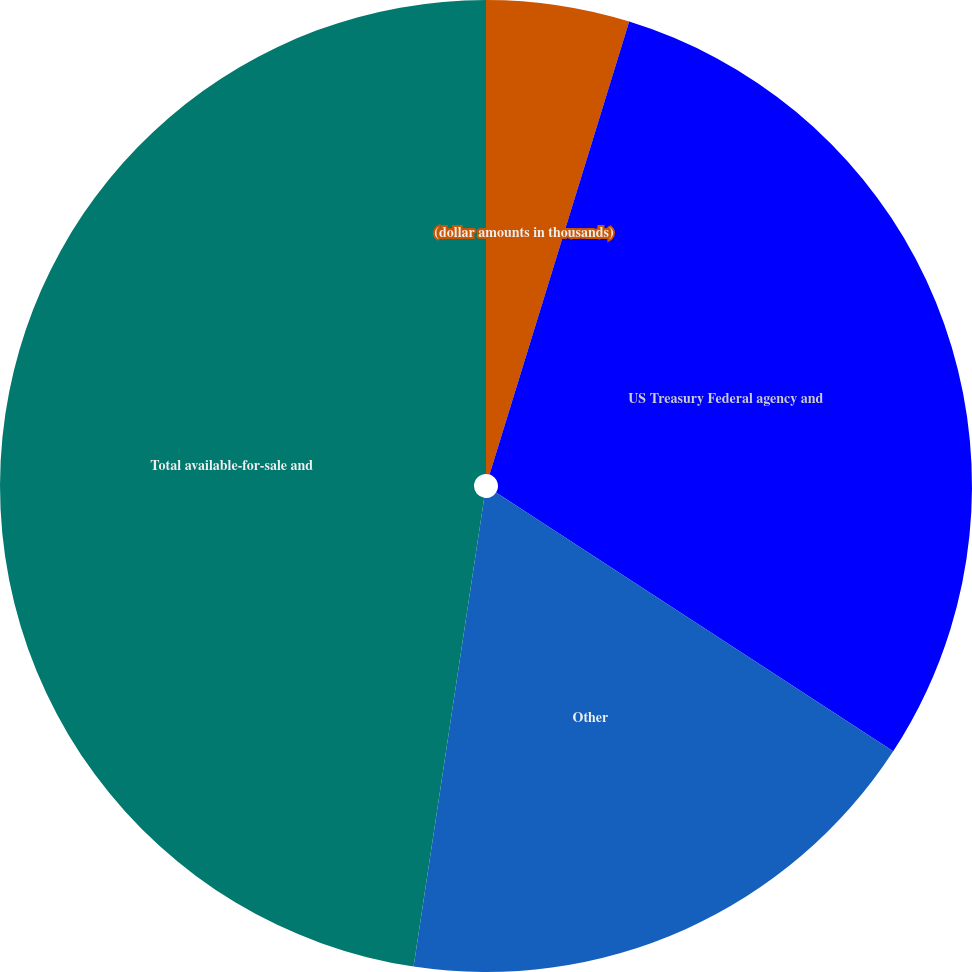<chart> <loc_0><loc_0><loc_500><loc_500><pie_chart><fcel>(dollar amounts in thousands)<fcel>US Treasury Federal agency and<fcel>Other<fcel>Total available-for-sale and<fcel>Duration in years (1)<nl><fcel>4.76%<fcel>29.43%<fcel>18.19%<fcel>47.62%<fcel>0.0%<nl></chart> 